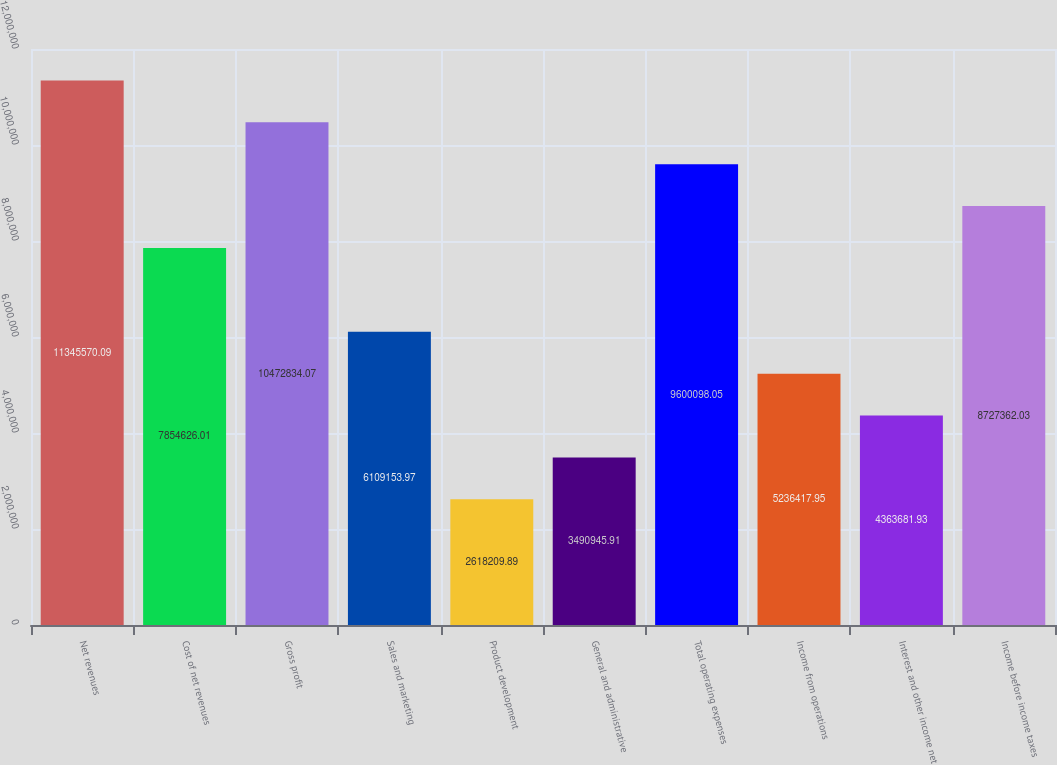Convert chart to OTSL. <chart><loc_0><loc_0><loc_500><loc_500><bar_chart><fcel>Net revenues<fcel>Cost of net revenues<fcel>Gross profit<fcel>Sales and marketing<fcel>Product development<fcel>General and administrative<fcel>Total operating expenses<fcel>Income from operations<fcel>Interest and other income net<fcel>Income before income taxes<nl><fcel>1.13456e+07<fcel>7.85463e+06<fcel>1.04728e+07<fcel>6.10915e+06<fcel>2.61821e+06<fcel>3.49095e+06<fcel>9.6001e+06<fcel>5.23642e+06<fcel>4.36368e+06<fcel>8.72736e+06<nl></chart> 